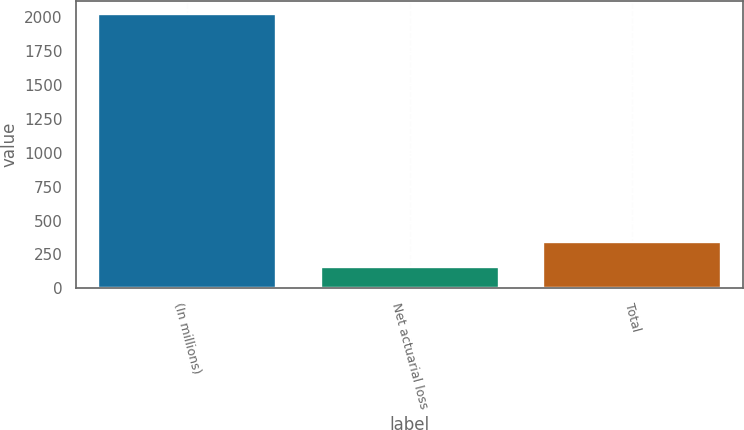Convert chart. <chart><loc_0><loc_0><loc_500><loc_500><bar_chart><fcel>(In millions)<fcel>Net actuarial loss<fcel>Total<nl><fcel>2017<fcel>157<fcel>343<nl></chart> 